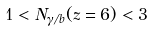<formula> <loc_0><loc_0><loc_500><loc_500>1 < N _ { \gamma / b } ( z = 6 ) < 3</formula> 